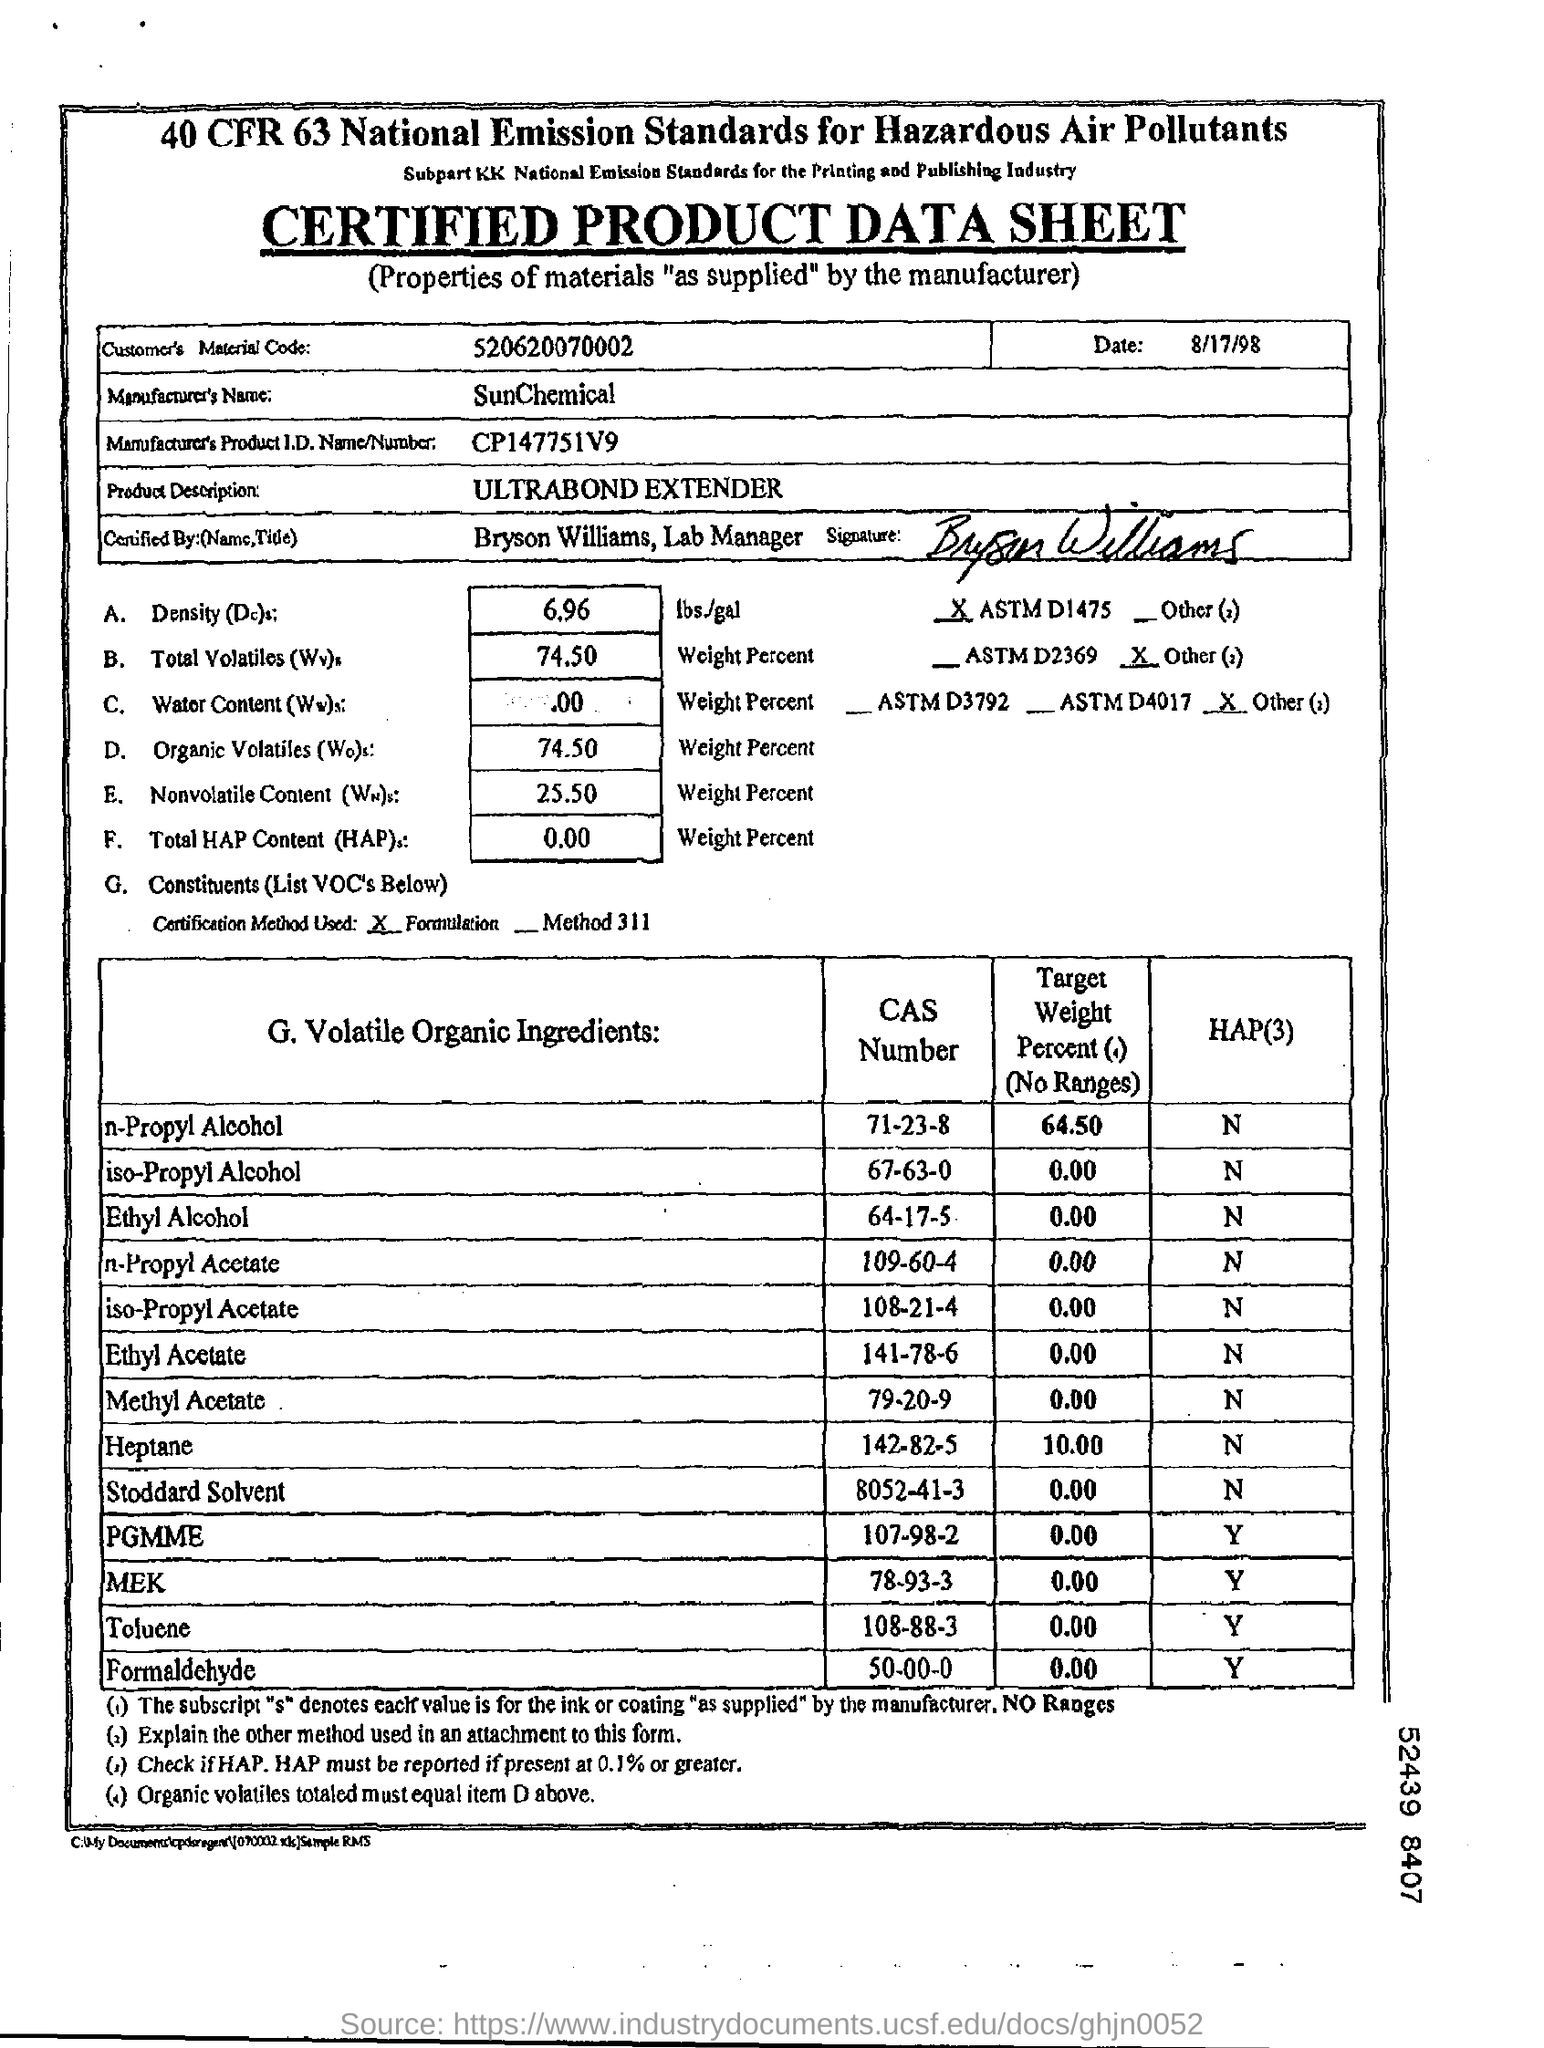What is the Sheet Name ?
Keep it short and to the point. Certified product data sheet. What is the Customer's Material Code ?
Ensure brevity in your answer.  520620070002. What is the Manufacture's Name ?
Give a very brief answer. SunChemical. What is the date mentioned in the top of the document ?
Ensure brevity in your answer.  8/17/98. What is the Manufacture's Product Id Number ?
Your answer should be compact. CP147751V9. What is written in the Product Description  Field ?
Your answer should be very brief. ULTRABOND EXTENDER. What is the CAS Number for Ethyl Alcohol ?
Your response must be concise. 64-17-5. 